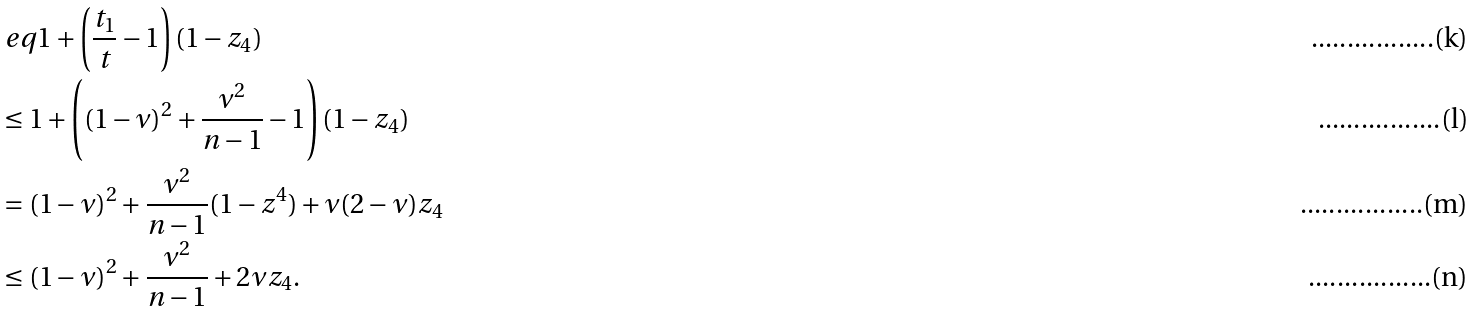Convert formula to latex. <formula><loc_0><loc_0><loc_500><loc_500>& \ e q 1 + \left ( \frac { t _ { 1 } } { t } - 1 \right ) ( 1 - z _ { 4 } ) \\ & \leq 1 + \left ( ( 1 - \nu ) ^ { 2 } + \frac { \nu ^ { 2 } } { n - 1 } - 1 \right ) ( 1 - z _ { 4 } ) \\ & = ( 1 - \nu ) ^ { 2 } + \frac { \nu ^ { 2 } } { n - 1 } ( 1 - z ^ { 4 } ) + \nu ( 2 - \nu ) z _ { 4 } \\ & \leq ( 1 - \nu ) ^ { 2 } + \frac { \nu ^ { 2 } } { n - 1 } + 2 \nu z _ { 4 } .</formula> 